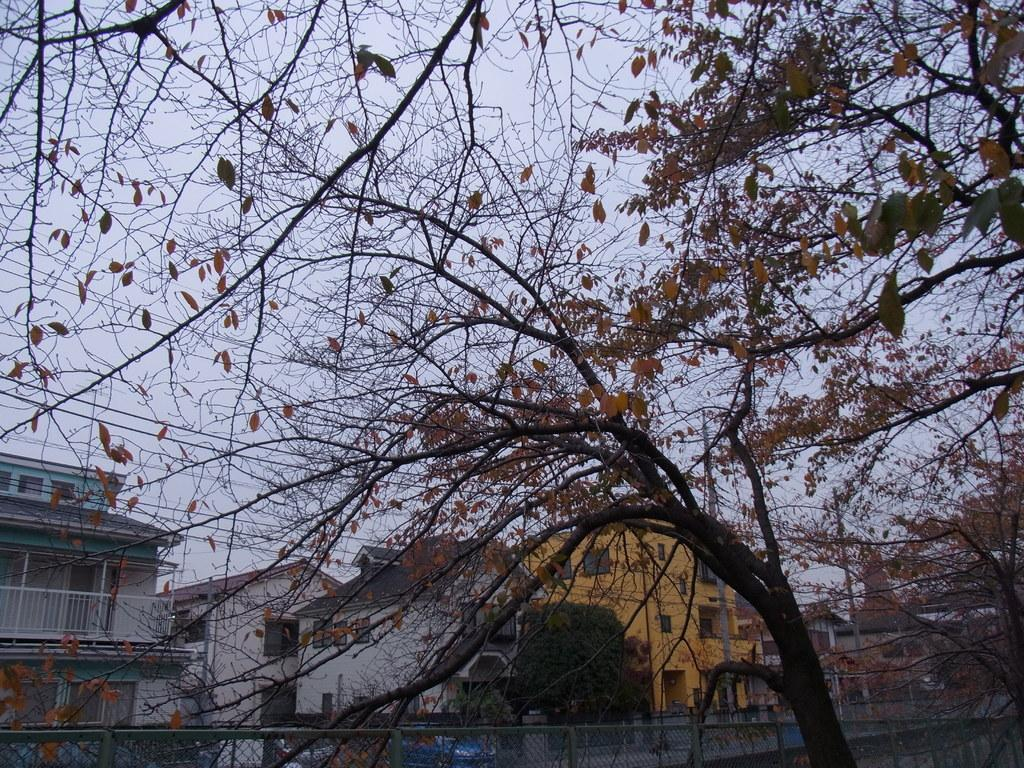What type of natural elements can be seen in the image? There are trees in the image. What man-made structure is present in the image? There is a fence in the image. What can be seen in the distance in the image? There are buildings in the background of the image. How do the buildings differ from one another in the image? The buildings have different colors. What else can be seen in the background of the image? There are electrical lines in the background of the image. What part of the natural environment is visible in the image? The sky is visible in the image. What is the price of the fog in the image? There is no fog present in the image, so it is not possible to determine a price for it. Where is the meeting taking place in the image? There is no meeting depicted in the image; it features trees, a fence, buildings, electrical lines, and the sky. 